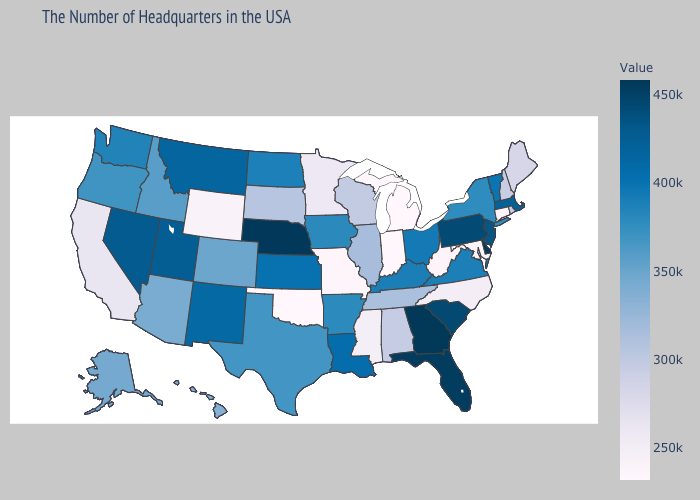Does Georgia have the highest value in the USA?
Short answer required. Yes. Which states have the lowest value in the West?
Write a very short answer. Wyoming. Is the legend a continuous bar?
Short answer required. Yes. Among the states that border Massachusetts , which have the highest value?
Give a very brief answer. Vermont. Among the states that border New Mexico , which have the lowest value?
Keep it brief. Oklahoma. 